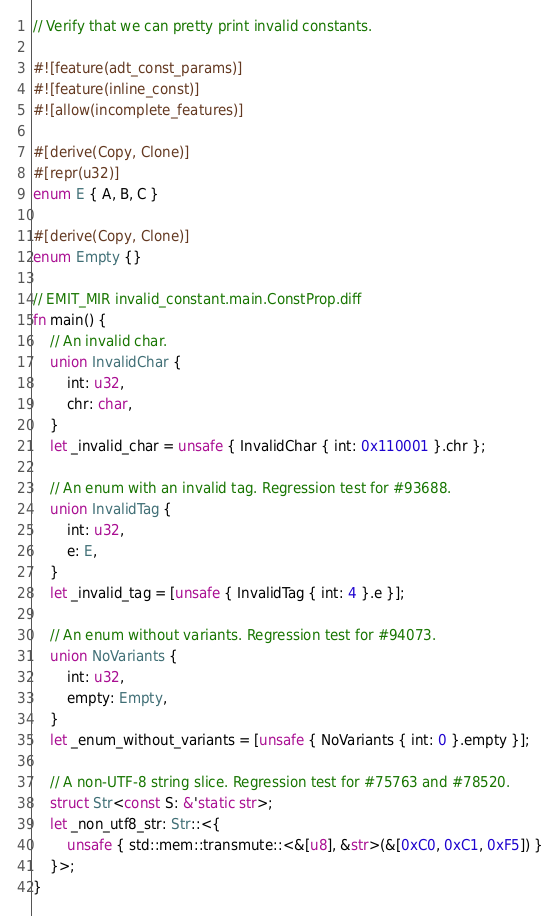<code> <loc_0><loc_0><loc_500><loc_500><_Rust_>// Verify that we can pretty print invalid constants.

#![feature(adt_const_params)]
#![feature(inline_const)]
#![allow(incomplete_features)]

#[derive(Copy, Clone)]
#[repr(u32)]
enum E { A, B, C }

#[derive(Copy, Clone)]
enum Empty {}

// EMIT_MIR invalid_constant.main.ConstProp.diff
fn main() {
    // An invalid char.
    union InvalidChar {
        int: u32,
        chr: char,
    }
    let _invalid_char = unsafe { InvalidChar { int: 0x110001 }.chr };

    // An enum with an invalid tag. Regression test for #93688.
    union InvalidTag {
        int: u32,
        e: E,
    }
    let _invalid_tag = [unsafe { InvalidTag { int: 4 }.e }];

    // An enum without variants. Regression test for #94073.
    union NoVariants {
        int: u32,
        empty: Empty,
    }
    let _enum_without_variants = [unsafe { NoVariants { int: 0 }.empty }];

    // A non-UTF-8 string slice. Regression test for #75763 and #78520.
    struct Str<const S: &'static str>;
    let _non_utf8_str: Str::<{
        unsafe { std::mem::transmute::<&[u8], &str>(&[0xC0, 0xC1, 0xF5]) }
    }>;
}
</code> 